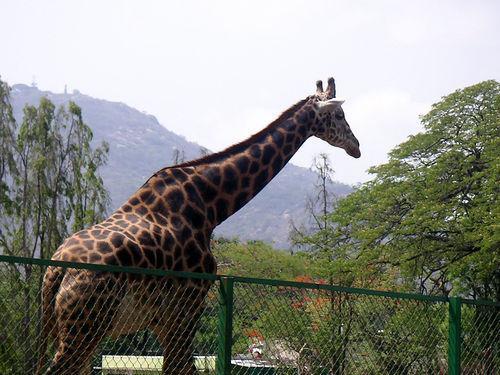How many giraffes are there?
Give a very brief answer. 1. How many giraffes are in the image?
Give a very brief answer. 1. How many giraffes are in the cage?
Give a very brief answer. 1. How many zebras are visible?
Give a very brief answer. 0. 